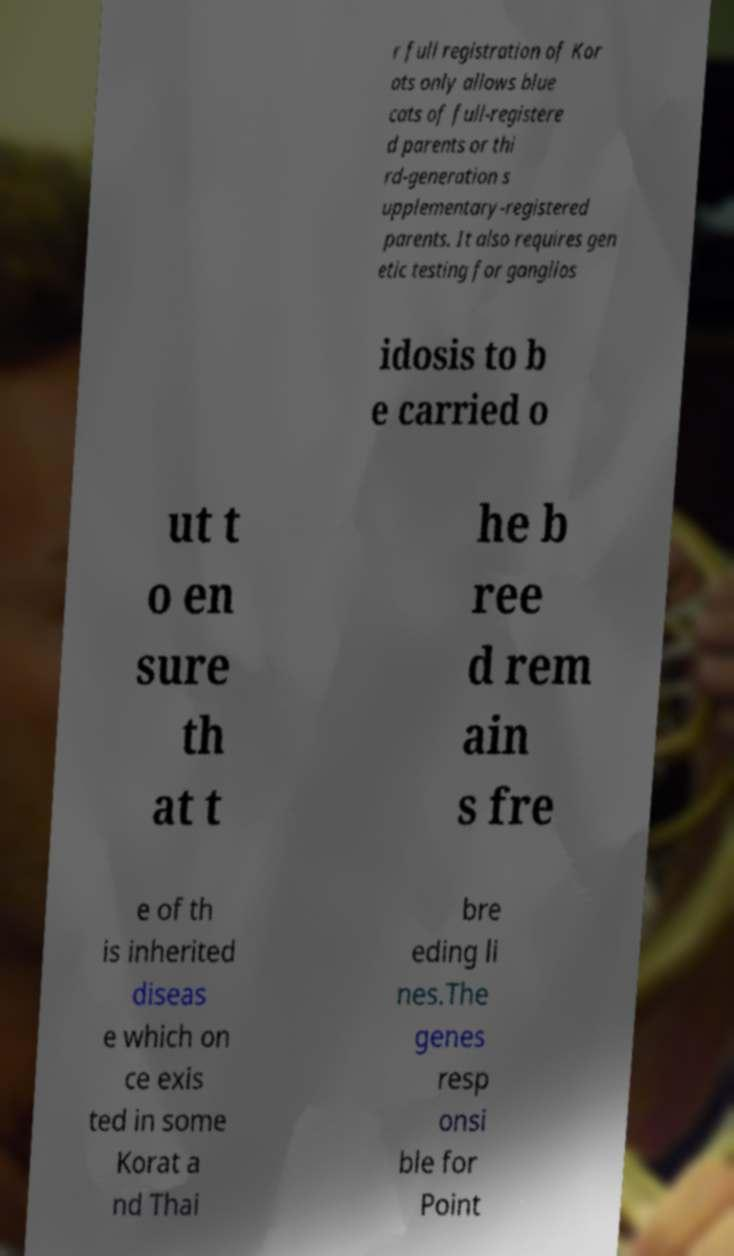Could you assist in decoding the text presented in this image and type it out clearly? r full registration of Kor ats only allows blue cats of full-registere d parents or thi rd-generation s upplementary-registered parents. It also requires gen etic testing for ganglios idosis to b e carried o ut t o en sure th at t he b ree d rem ain s fre e of th is inherited diseas e which on ce exis ted in some Korat a nd Thai bre eding li nes.The genes resp onsi ble for Point 